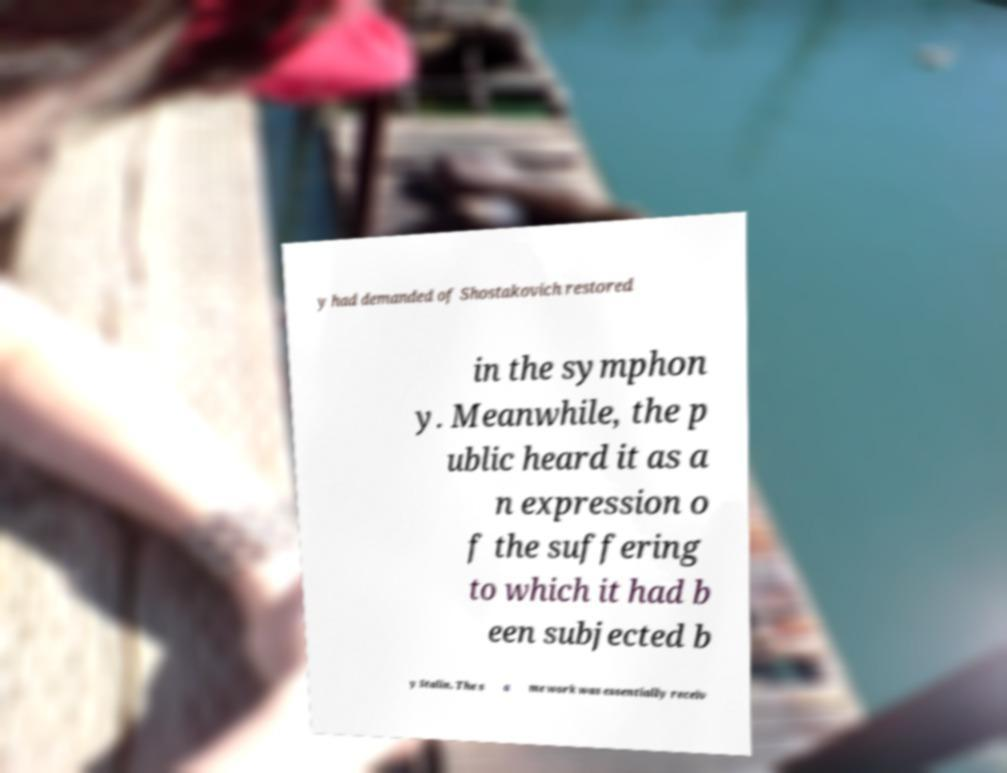Can you read and provide the text displayed in the image?This photo seems to have some interesting text. Can you extract and type it out for me? y had demanded of Shostakovich restored in the symphon y. Meanwhile, the p ublic heard it as a n expression o f the suffering to which it had b een subjected b y Stalin. The s a me work was essentially receiv 